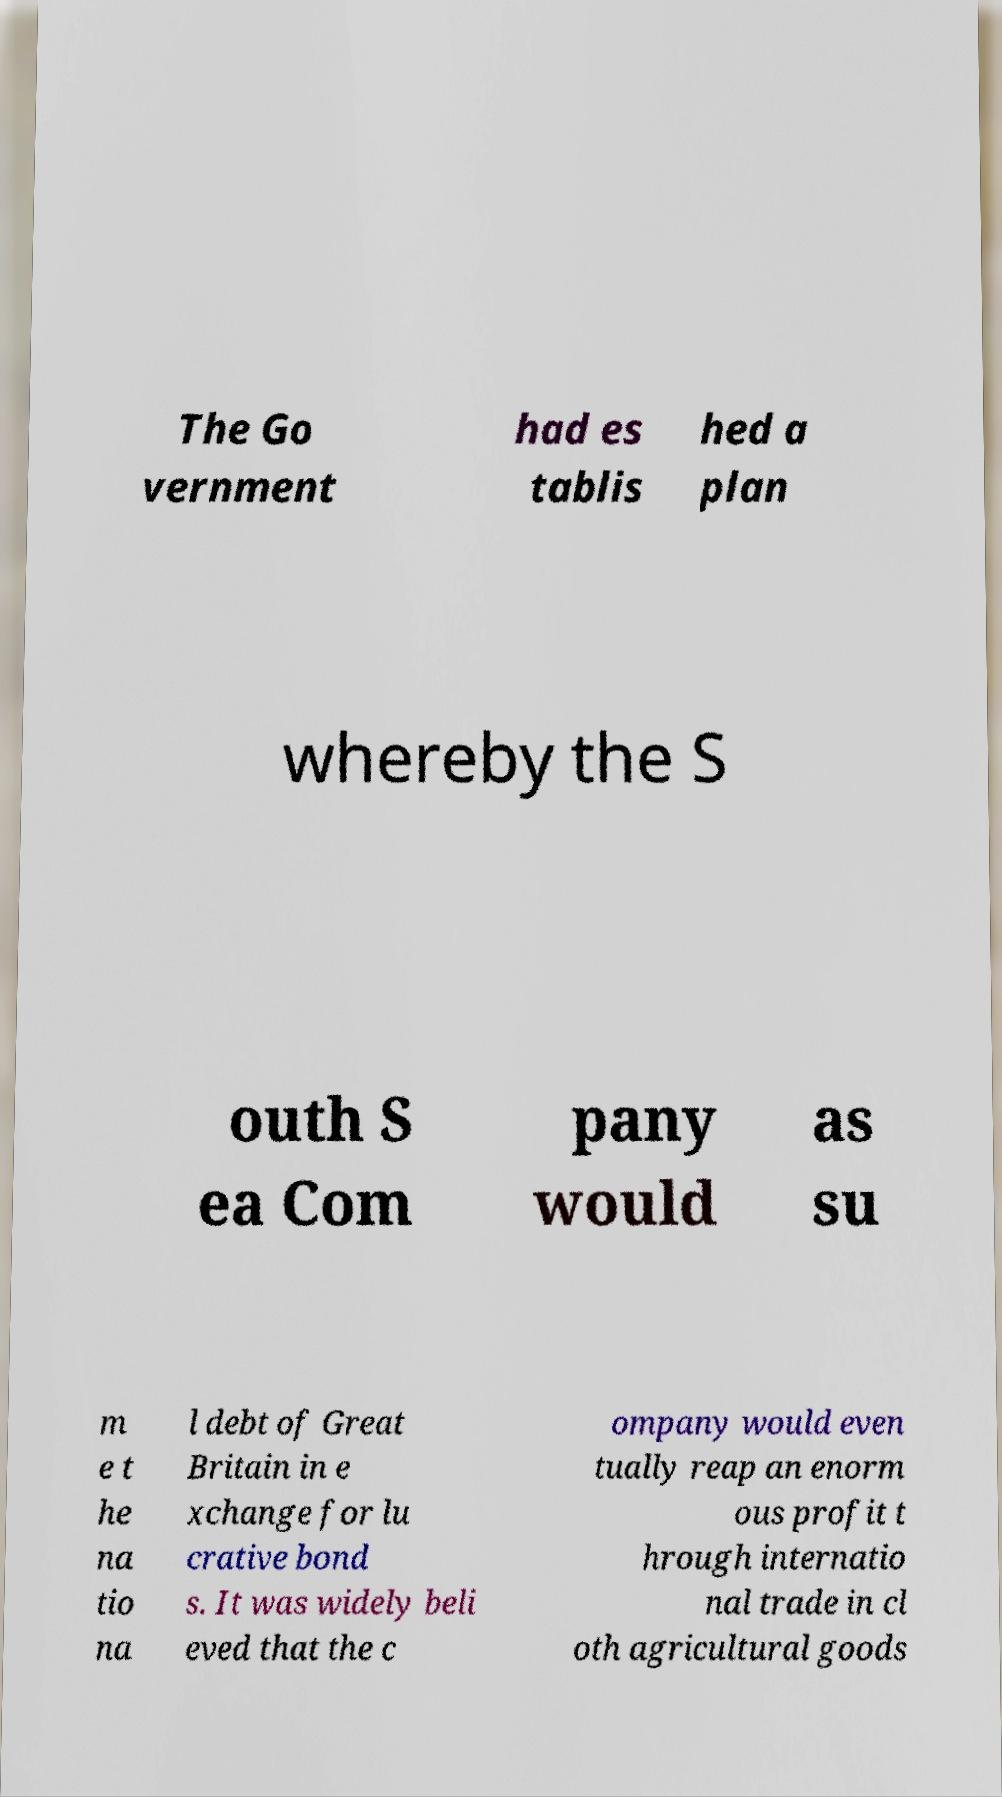I need the written content from this picture converted into text. Can you do that? The Go vernment had es tablis hed a plan whereby the S outh S ea Com pany would as su m e t he na tio na l debt of Great Britain in e xchange for lu crative bond s. It was widely beli eved that the c ompany would even tually reap an enorm ous profit t hrough internatio nal trade in cl oth agricultural goods 